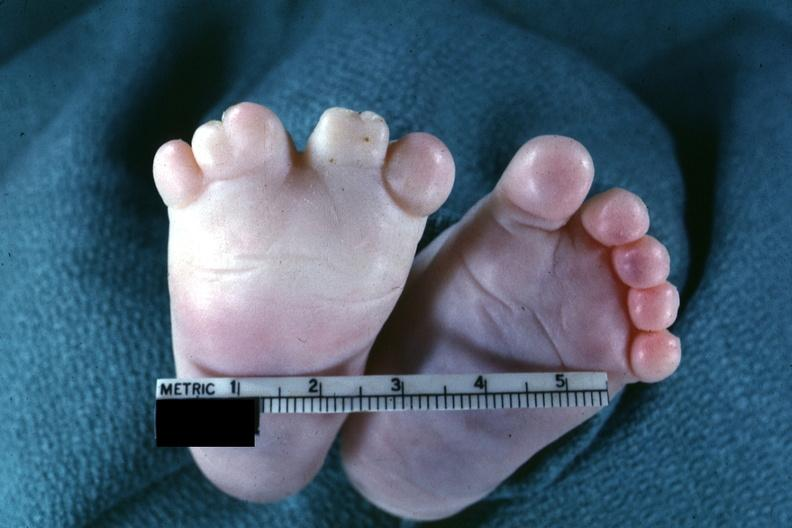re extremities present?
Answer the question using a single word or phrase. Yes 